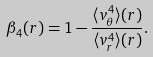Convert formula to latex. <formula><loc_0><loc_0><loc_500><loc_500>\beta _ { 4 } ( r ) = 1 - \frac { \langle v _ { \theta } ^ { 4 } \rangle ( r ) } { \langle v _ { r } ^ { 4 } \rangle ( r ) } .</formula> 